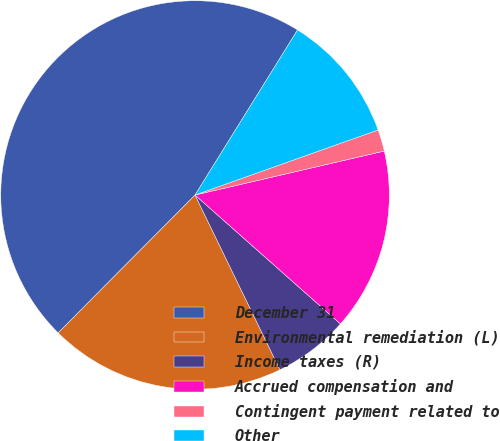Convert chart to OTSL. <chart><loc_0><loc_0><loc_500><loc_500><pie_chart><fcel>December 31<fcel>Environmental remediation (L)<fcel>Income taxes (R)<fcel>Accrued compensation and<fcel>Contingent payment related to<fcel>Other<nl><fcel>46.41%<fcel>19.64%<fcel>6.26%<fcel>15.18%<fcel>1.8%<fcel>10.72%<nl></chart> 